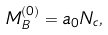Convert formula to latex. <formula><loc_0><loc_0><loc_500><loc_500>M _ { B } ^ { ( 0 ) } = a _ { 0 } N _ { c } ,</formula> 